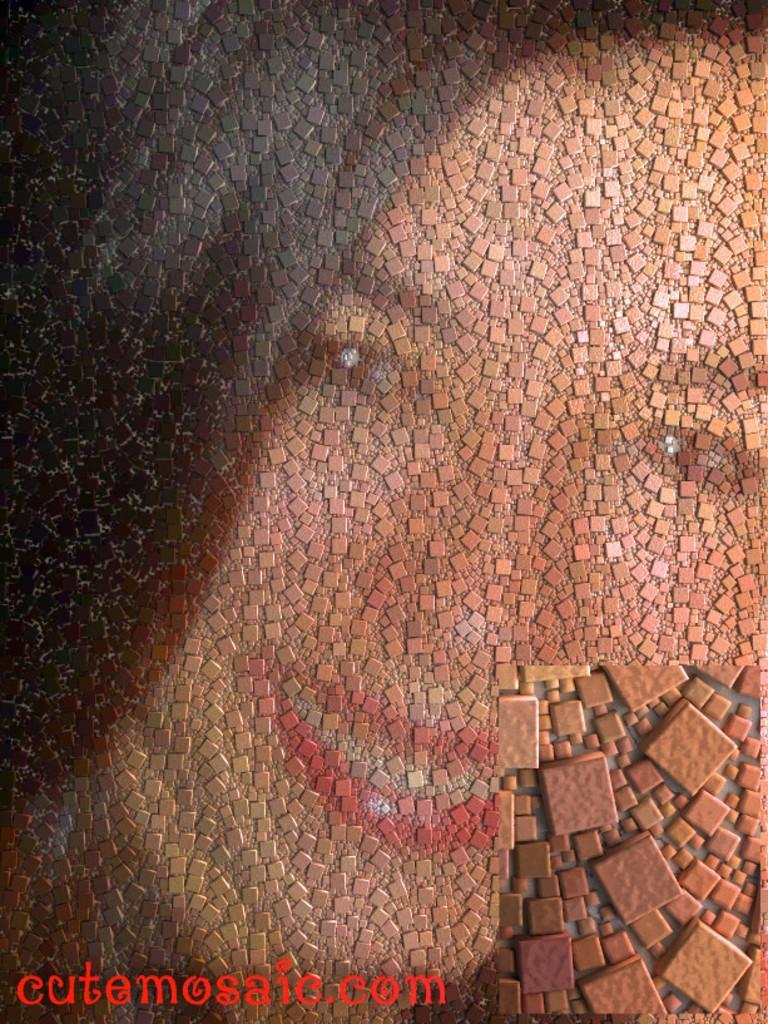Describe this image in one or two sentences. In this picture, we see the painting of the woman on the wall. She is smiling. At the bottom, we see some text written in red color. This might be an edited image. 